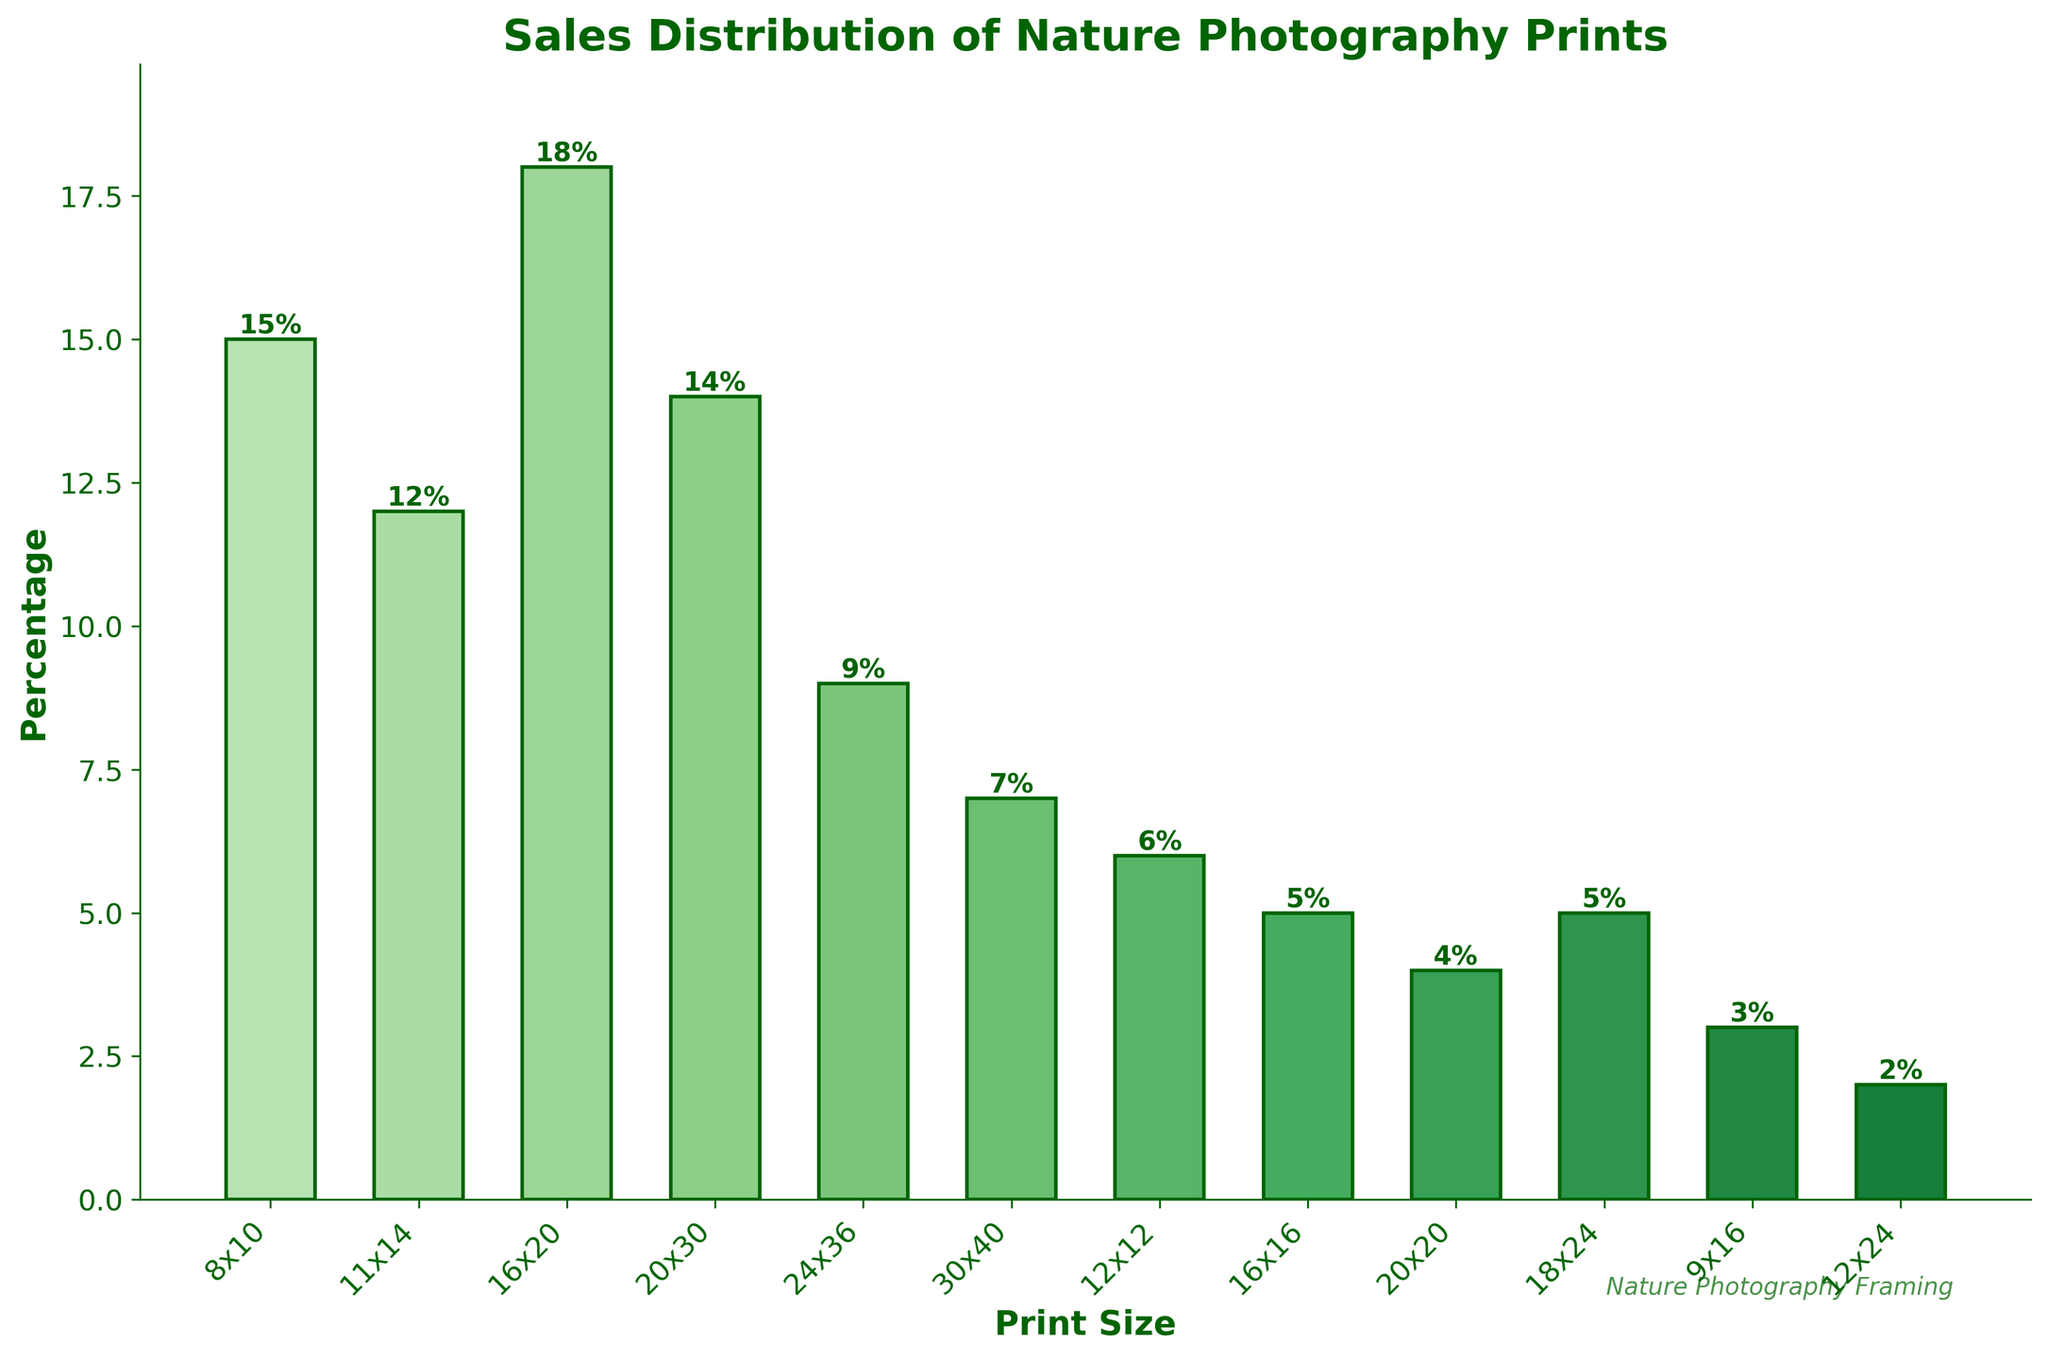What print size and aspect ratio has the highest sales percentage? The bar representing the print size 16x20 and aspect ratio 4:5 is the highest, indicating 18% sales.
Answer: 16x20, 4:5 Which print size and aspect ratio has the lowest sales percentage? The bar representing the print size 12x24 and aspect ratio 1:2 is the shortest, indicating 2% sales.
Answer: 12x24, 1:2 What is the total sales percentage for print sizes with an aspect ratio of 2:3? The print sizes with an aspect ratio of 2:3 are 20x30 and 24x36, with sales percentages of 14% and 9% respectively. Summing them up: 14 + 9 = 23%.
Answer: 23% How do sales percentages compare between print sizes 8x10 (4:5) and 11x14 (11:14)? The bar for 8x10 is slightly higher than 11x14. The sales percentages are 15% and 12% respectively. Since 15% > 12%, 8x10 has a higher sales percentage.
Answer: 8x10 has higher sales What is the combined sales percentage of square print sizes (1:1 aspect ratio)? The square print sizes are 12x12, 16x16, and 20x20 with sales percentages of 6%, 5%, and 4% respectively. Adding them together: 6 + 5 + 4 = 15%.
Answer: 15% Which size had a more significant difference in sales when comparing 20x30 and 30x40? The sales percentages for 20x30 and 30x40 are 14% and 7%, respectively. The difference is 14 - 7 = 7%.
Answer: 7% How does the sales percentage of the most popular size compare to the overall average sales percentage? The most popular size is 16x20 with 18%. To find the overall average, sum all percentages: 15 + 12 + 18 + 14 + 9 + 7 + 6 + 5 + 4 + 5 + 3 + 2 = 100%. The average percentage is 100% / 12 = 8.33%. Comparing the most popular size (18%) to the average (8.33%): 18% > 8.33%.
Answer: 18% is greater than 8.33% What are the three least popular print sizes? The three shortest bars indicating the least sales percentages are for sizes 12x24 (2%), 9x16 (3%), and 20x20 (4%).
Answer: 12x24, 9x16, 20x20 What is the difference in sales percentage between the most popular and the least popular print sizes? The sales percentage for the most popular size (16x20, 4:5) is 18%. The least popular size (12x24, 1:2) has 2%. The difference is 18 - 2 = 16%.
Answer: 16% What is the median sales percentage of the data? To find the median, first, order the percentages: 2, 3, 4, 5, 5, 6, 7, 9, 12, 14, 15, 18. There are 12 data points, so the median is the average of the 6th and 7th values: (6 + 7) / 2 = 6.5%.
Answer: 6.5% 